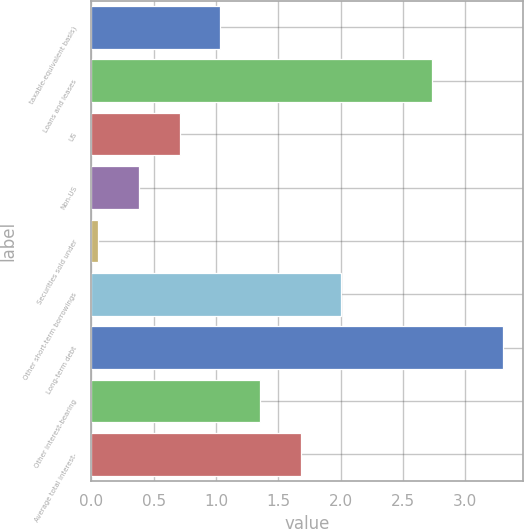<chart> <loc_0><loc_0><loc_500><loc_500><bar_chart><fcel>taxable-equivalent basis)<fcel>Loans and leases<fcel>US<fcel>Non-US<fcel>Securities sold under<fcel>Other short-term borrowings<fcel>Long-term debt<fcel>Other interest-bearing<fcel>Average total interest-<nl><fcel>1.03<fcel>2.73<fcel>0.71<fcel>0.38<fcel>0.05<fcel>2<fcel>3.3<fcel>1.35<fcel>1.68<nl></chart> 